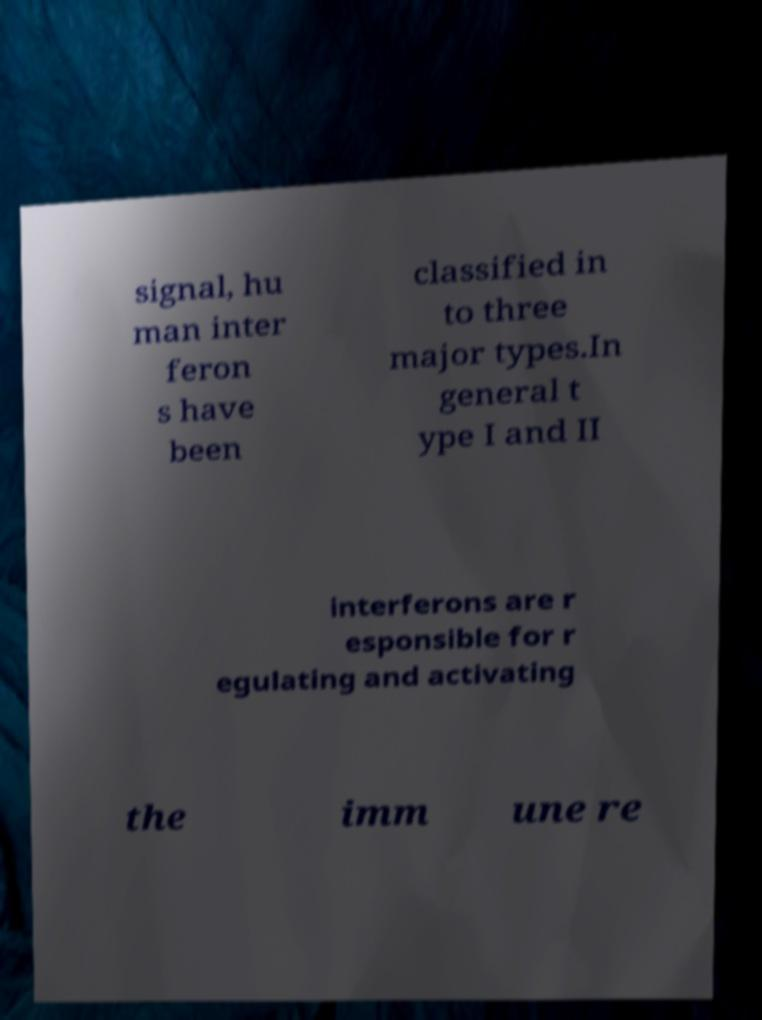Please read and relay the text visible in this image. What does it say? signal, hu man inter feron s have been classified in to three major types.In general t ype I and II interferons are r esponsible for r egulating and activating the imm une re 